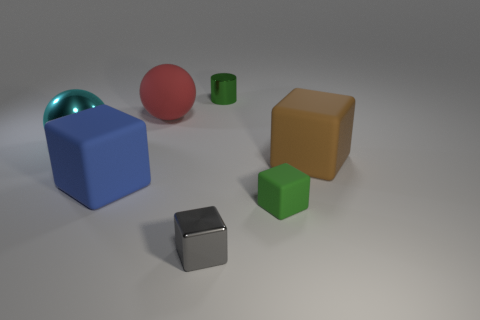What is the size of the cyan ball that is made of the same material as the tiny gray thing?
Your answer should be very brief. Large. What color is the big matte thing that is right of the green object in front of the blue matte object?
Your response must be concise. Brown. What number of large blue cubes are in front of the small shiny thing in front of the small block to the right of the tiny green metal cylinder?
Ensure brevity in your answer.  0. There is a large blue rubber object that is in front of the big shiny sphere; is it the same shape as the tiny green thing that is behind the large red sphere?
Your response must be concise. No. How many objects are large blue objects or tiny green matte things?
Ensure brevity in your answer.  2. What material is the small green thing that is behind the large matte block to the left of the big brown rubber block?
Give a very brief answer. Metal. Is there a small rubber thing that has the same color as the tiny shiny cylinder?
Your answer should be compact. Yes. What color is the rubber sphere that is the same size as the blue object?
Keep it short and to the point. Red. There is a green thing to the left of the small object that is on the right side of the tiny object that is behind the cyan shiny ball; what is its material?
Keep it short and to the point. Metal. Do the metal cylinder and the tiny rubber object that is in front of the metal sphere have the same color?
Provide a short and direct response. Yes. 